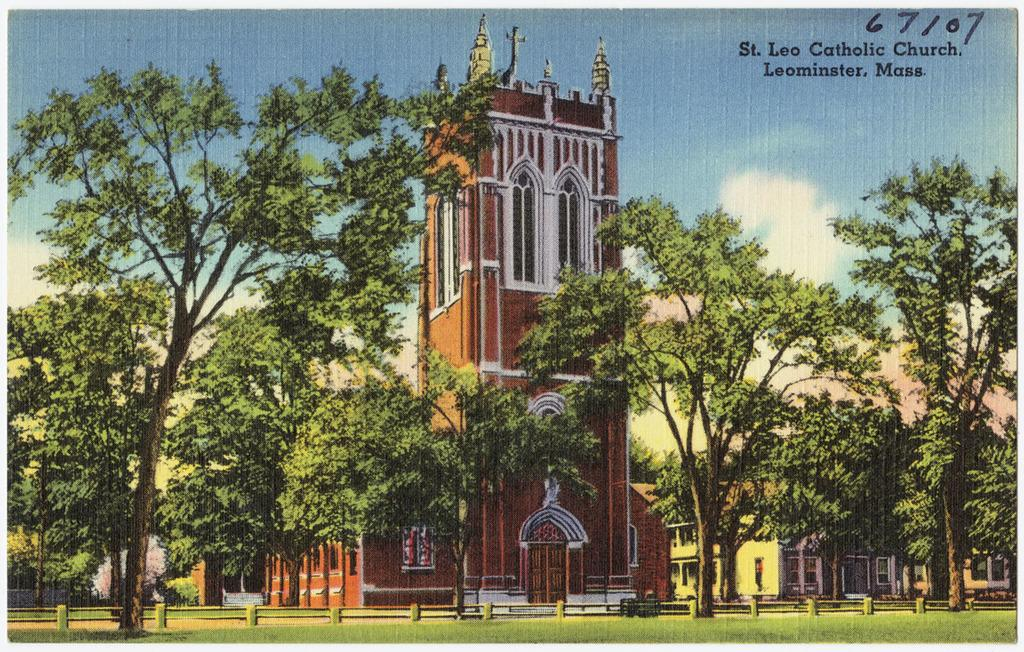<image>
Give a short and clear explanation of the subsequent image. A large grassy green area with a church called St. Leo Cathoic Church in Mass. 